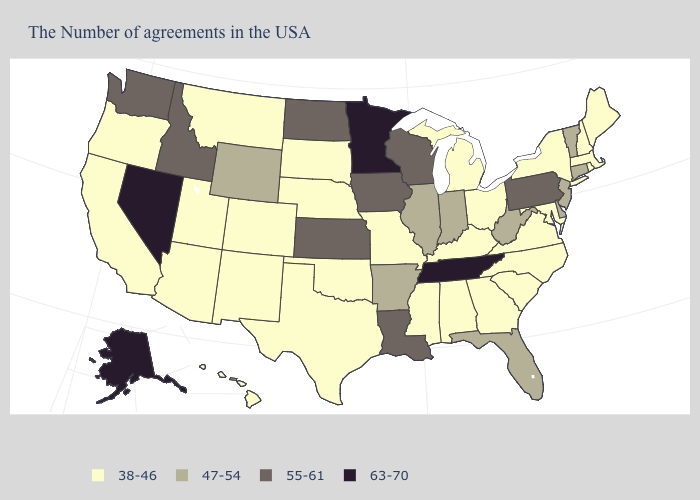Does Arizona have the lowest value in the West?
Answer briefly. Yes. Which states have the lowest value in the USA?
Write a very short answer. Maine, Massachusetts, Rhode Island, New Hampshire, New York, Maryland, Virginia, North Carolina, South Carolina, Ohio, Georgia, Michigan, Kentucky, Alabama, Mississippi, Missouri, Nebraska, Oklahoma, Texas, South Dakota, Colorado, New Mexico, Utah, Montana, Arizona, California, Oregon, Hawaii. Name the states that have a value in the range 38-46?
Be succinct. Maine, Massachusetts, Rhode Island, New Hampshire, New York, Maryland, Virginia, North Carolina, South Carolina, Ohio, Georgia, Michigan, Kentucky, Alabama, Mississippi, Missouri, Nebraska, Oklahoma, Texas, South Dakota, Colorado, New Mexico, Utah, Montana, Arizona, California, Oregon, Hawaii. What is the lowest value in the West?
Short answer required. 38-46. Name the states that have a value in the range 38-46?
Give a very brief answer. Maine, Massachusetts, Rhode Island, New Hampshire, New York, Maryland, Virginia, North Carolina, South Carolina, Ohio, Georgia, Michigan, Kentucky, Alabama, Mississippi, Missouri, Nebraska, Oklahoma, Texas, South Dakota, Colorado, New Mexico, Utah, Montana, Arizona, California, Oregon, Hawaii. Name the states that have a value in the range 47-54?
Concise answer only. Vermont, Connecticut, New Jersey, Delaware, West Virginia, Florida, Indiana, Illinois, Arkansas, Wyoming. Does Massachusetts have the highest value in the Northeast?
Short answer required. No. Name the states that have a value in the range 47-54?
Keep it brief. Vermont, Connecticut, New Jersey, Delaware, West Virginia, Florida, Indiana, Illinois, Arkansas, Wyoming. Among the states that border Maryland , does Delaware have the highest value?
Keep it brief. No. What is the value of Missouri?
Give a very brief answer. 38-46. What is the value of Texas?
Give a very brief answer. 38-46. Name the states that have a value in the range 63-70?
Quick response, please. Tennessee, Minnesota, Nevada, Alaska. Among the states that border South Carolina , which have the lowest value?
Short answer required. North Carolina, Georgia. Name the states that have a value in the range 47-54?
Short answer required. Vermont, Connecticut, New Jersey, Delaware, West Virginia, Florida, Indiana, Illinois, Arkansas, Wyoming. 